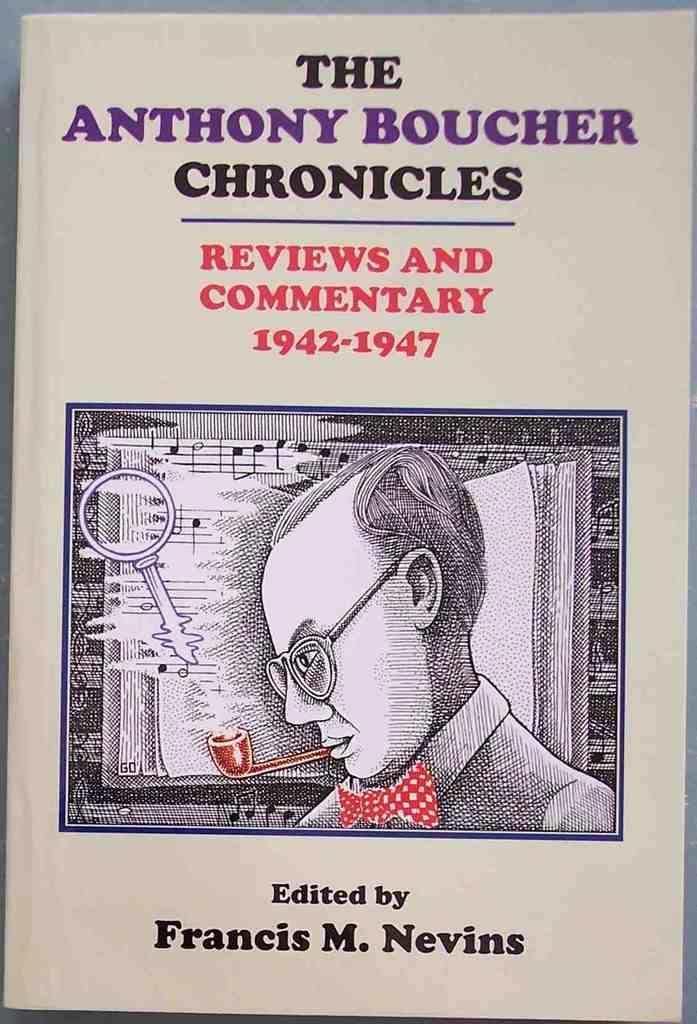What is the title of this book?
Offer a terse response. The anthony boucher chronicles. Who was this book edited by?
Your answer should be very brief. Francis m nevins. 